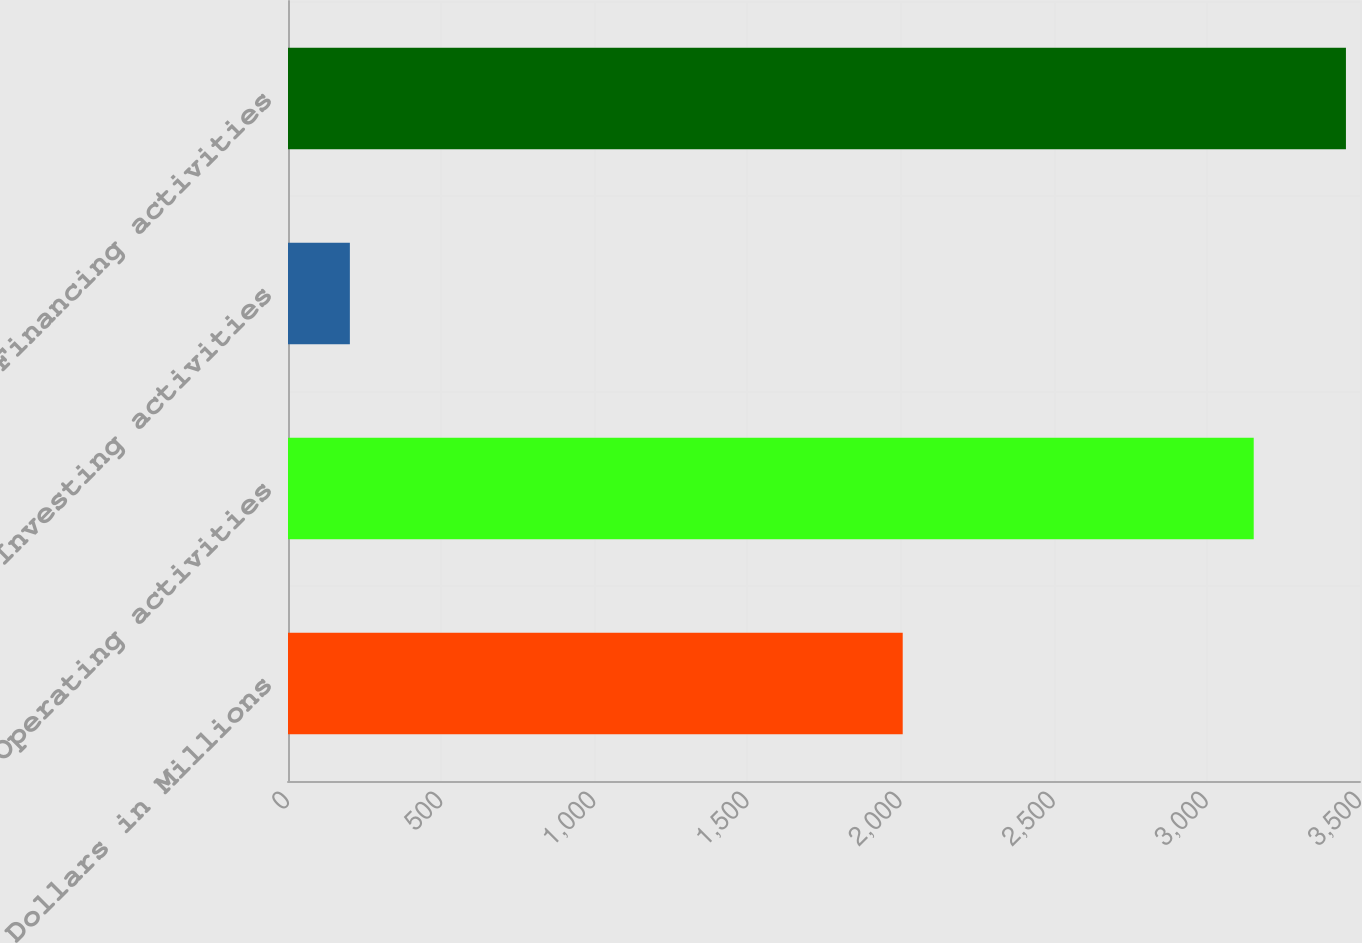Convert chart to OTSL. <chart><loc_0><loc_0><loc_500><loc_500><bar_chart><fcel>Dollars in Millions<fcel>Operating activities<fcel>Investing activities<fcel>Financing activities<nl><fcel>2007<fcel>3153<fcel>202<fcel>3454.1<nl></chart> 